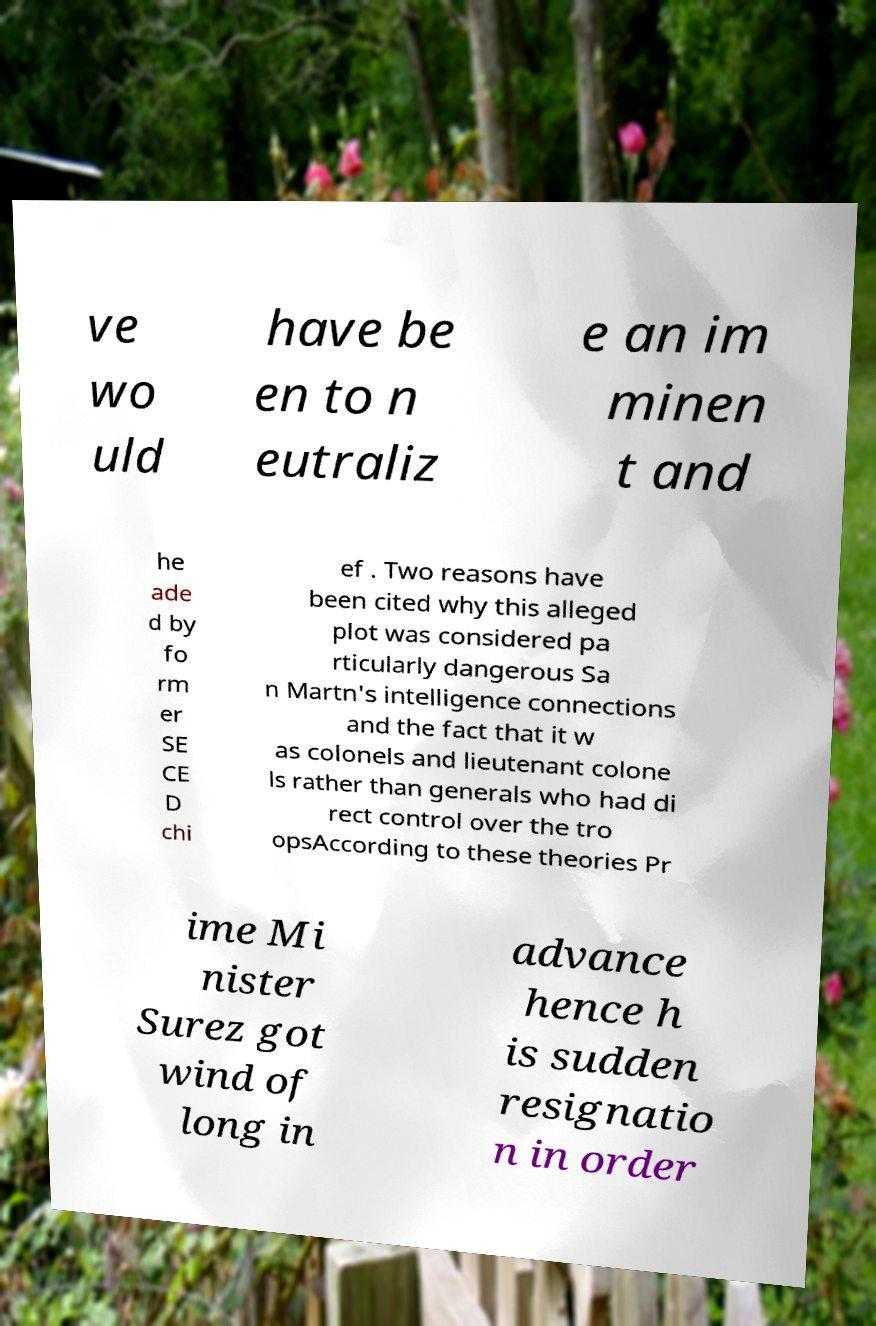For documentation purposes, I need the text within this image transcribed. Could you provide that? ve wo uld have be en to n eutraliz e an im minen t and he ade d by fo rm er SE CE D chi ef . Two reasons have been cited why this alleged plot was considered pa rticularly dangerous Sa n Martn's intelligence connections and the fact that it w as colonels and lieutenant colone ls rather than generals who had di rect control over the tro opsAccording to these theories Pr ime Mi nister Surez got wind of long in advance hence h is sudden resignatio n in order 